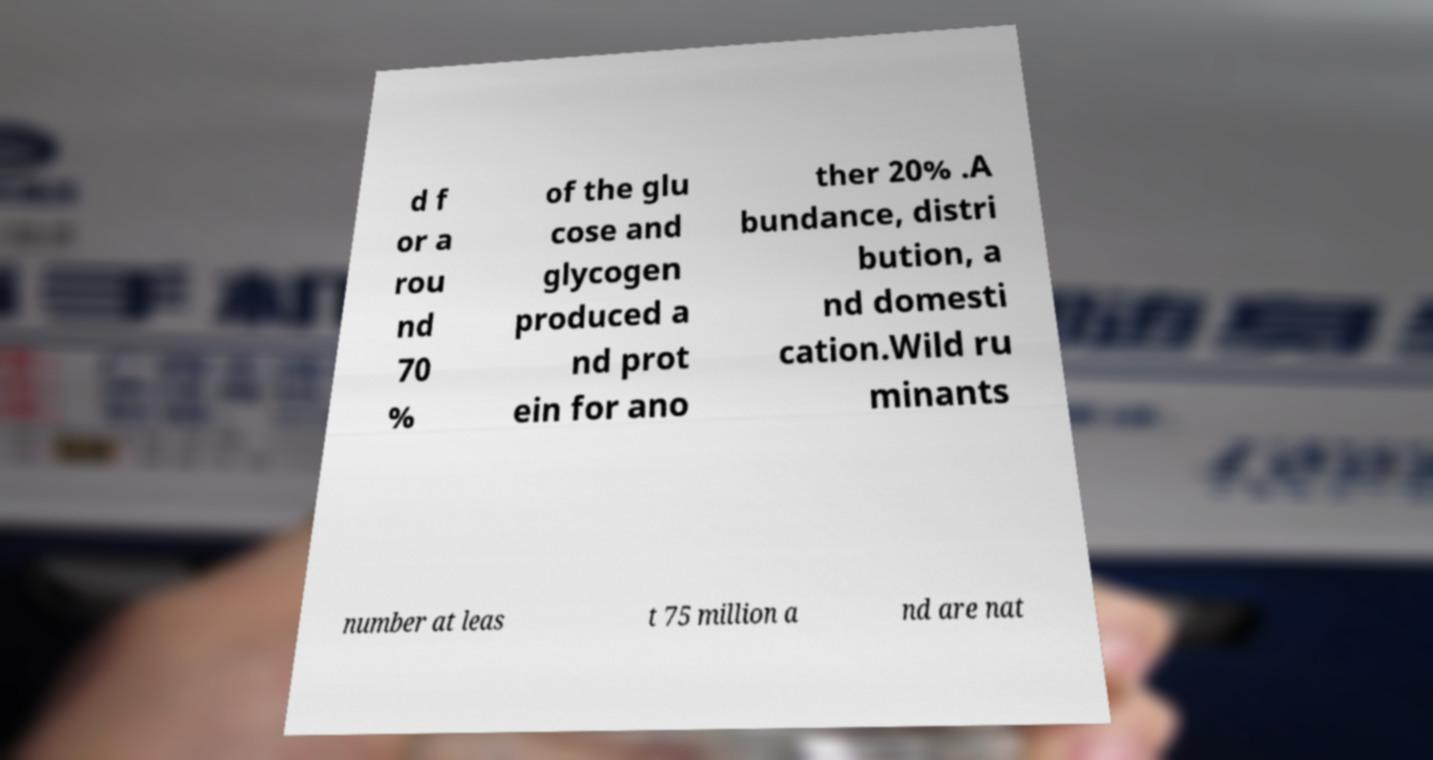What messages or text are displayed in this image? I need them in a readable, typed format. d f or a rou nd 70 % of the glu cose and glycogen produced a nd prot ein for ano ther 20% .A bundance, distri bution, a nd domesti cation.Wild ru minants number at leas t 75 million a nd are nat 